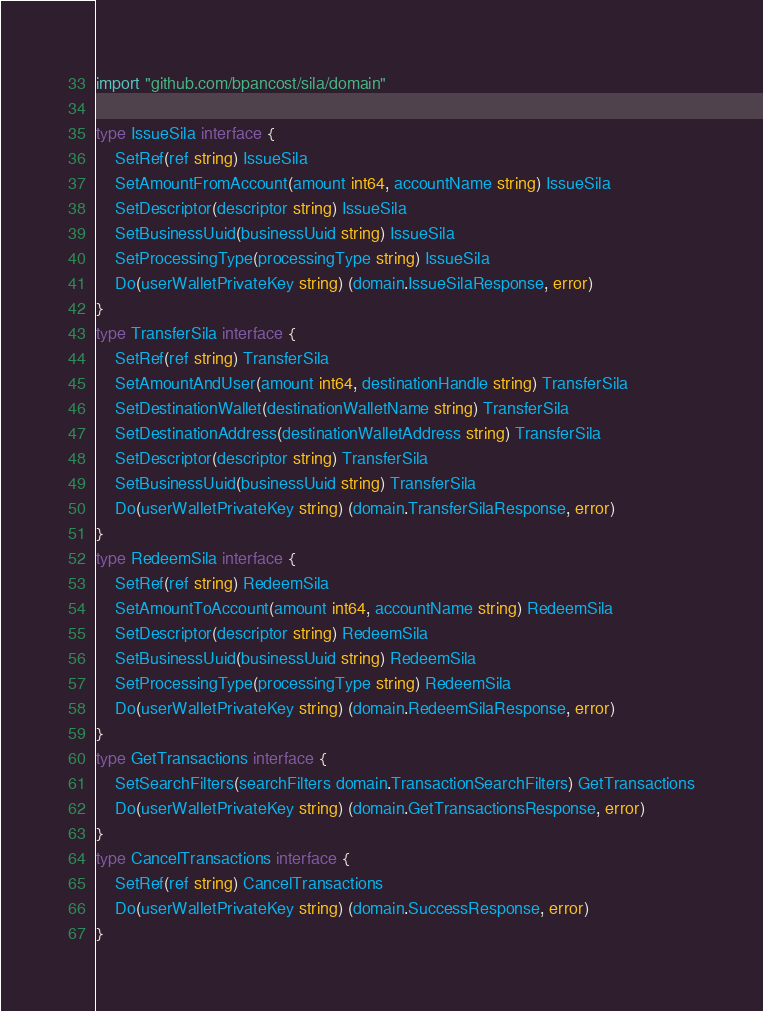Convert code to text. <code><loc_0><loc_0><loc_500><loc_500><_Go_>
import "github.com/bpancost/sila/domain"

type IssueSila interface {
	SetRef(ref string) IssueSila
	SetAmountFromAccount(amount int64, accountName string) IssueSila
	SetDescriptor(descriptor string) IssueSila
	SetBusinessUuid(businessUuid string) IssueSila
	SetProcessingType(processingType string) IssueSila
	Do(userWalletPrivateKey string) (domain.IssueSilaResponse, error)
}
type TransferSila interface {
	SetRef(ref string) TransferSila
	SetAmountAndUser(amount int64, destinationHandle string) TransferSila
	SetDestinationWallet(destinationWalletName string) TransferSila
	SetDestinationAddress(destinationWalletAddress string) TransferSila
	SetDescriptor(descriptor string) TransferSila
	SetBusinessUuid(businessUuid string) TransferSila
	Do(userWalletPrivateKey string) (domain.TransferSilaResponse, error)
}
type RedeemSila interface {
	SetRef(ref string) RedeemSila
	SetAmountToAccount(amount int64, accountName string) RedeemSila
	SetDescriptor(descriptor string) RedeemSila
	SetBusinessUuid(businessUuid string) RedeemSila
	SetProcessingType(processingType string) RedeemSila
	Do(userWalletPrivateKey string) (domain.RedeemSilaResponse, error)
}
type GetTransactions interface {
	SetSearchFilters(searchFilters domain.TransactionSearchFilters) GetTransactions
	Do(userWalletPrivateKey string) (domain.GetTransactionsResponse, error)
}
type CancelTransactions interface {
	SetRef(ref string) CancelTransactions
	Do(userWalletPrivateKey string) (domain.SuccessResponse, error)
}
</code> 